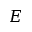Convert formula to latex. <formula><loc_0><loc_0><loc_500><loc_500>E</formula> 